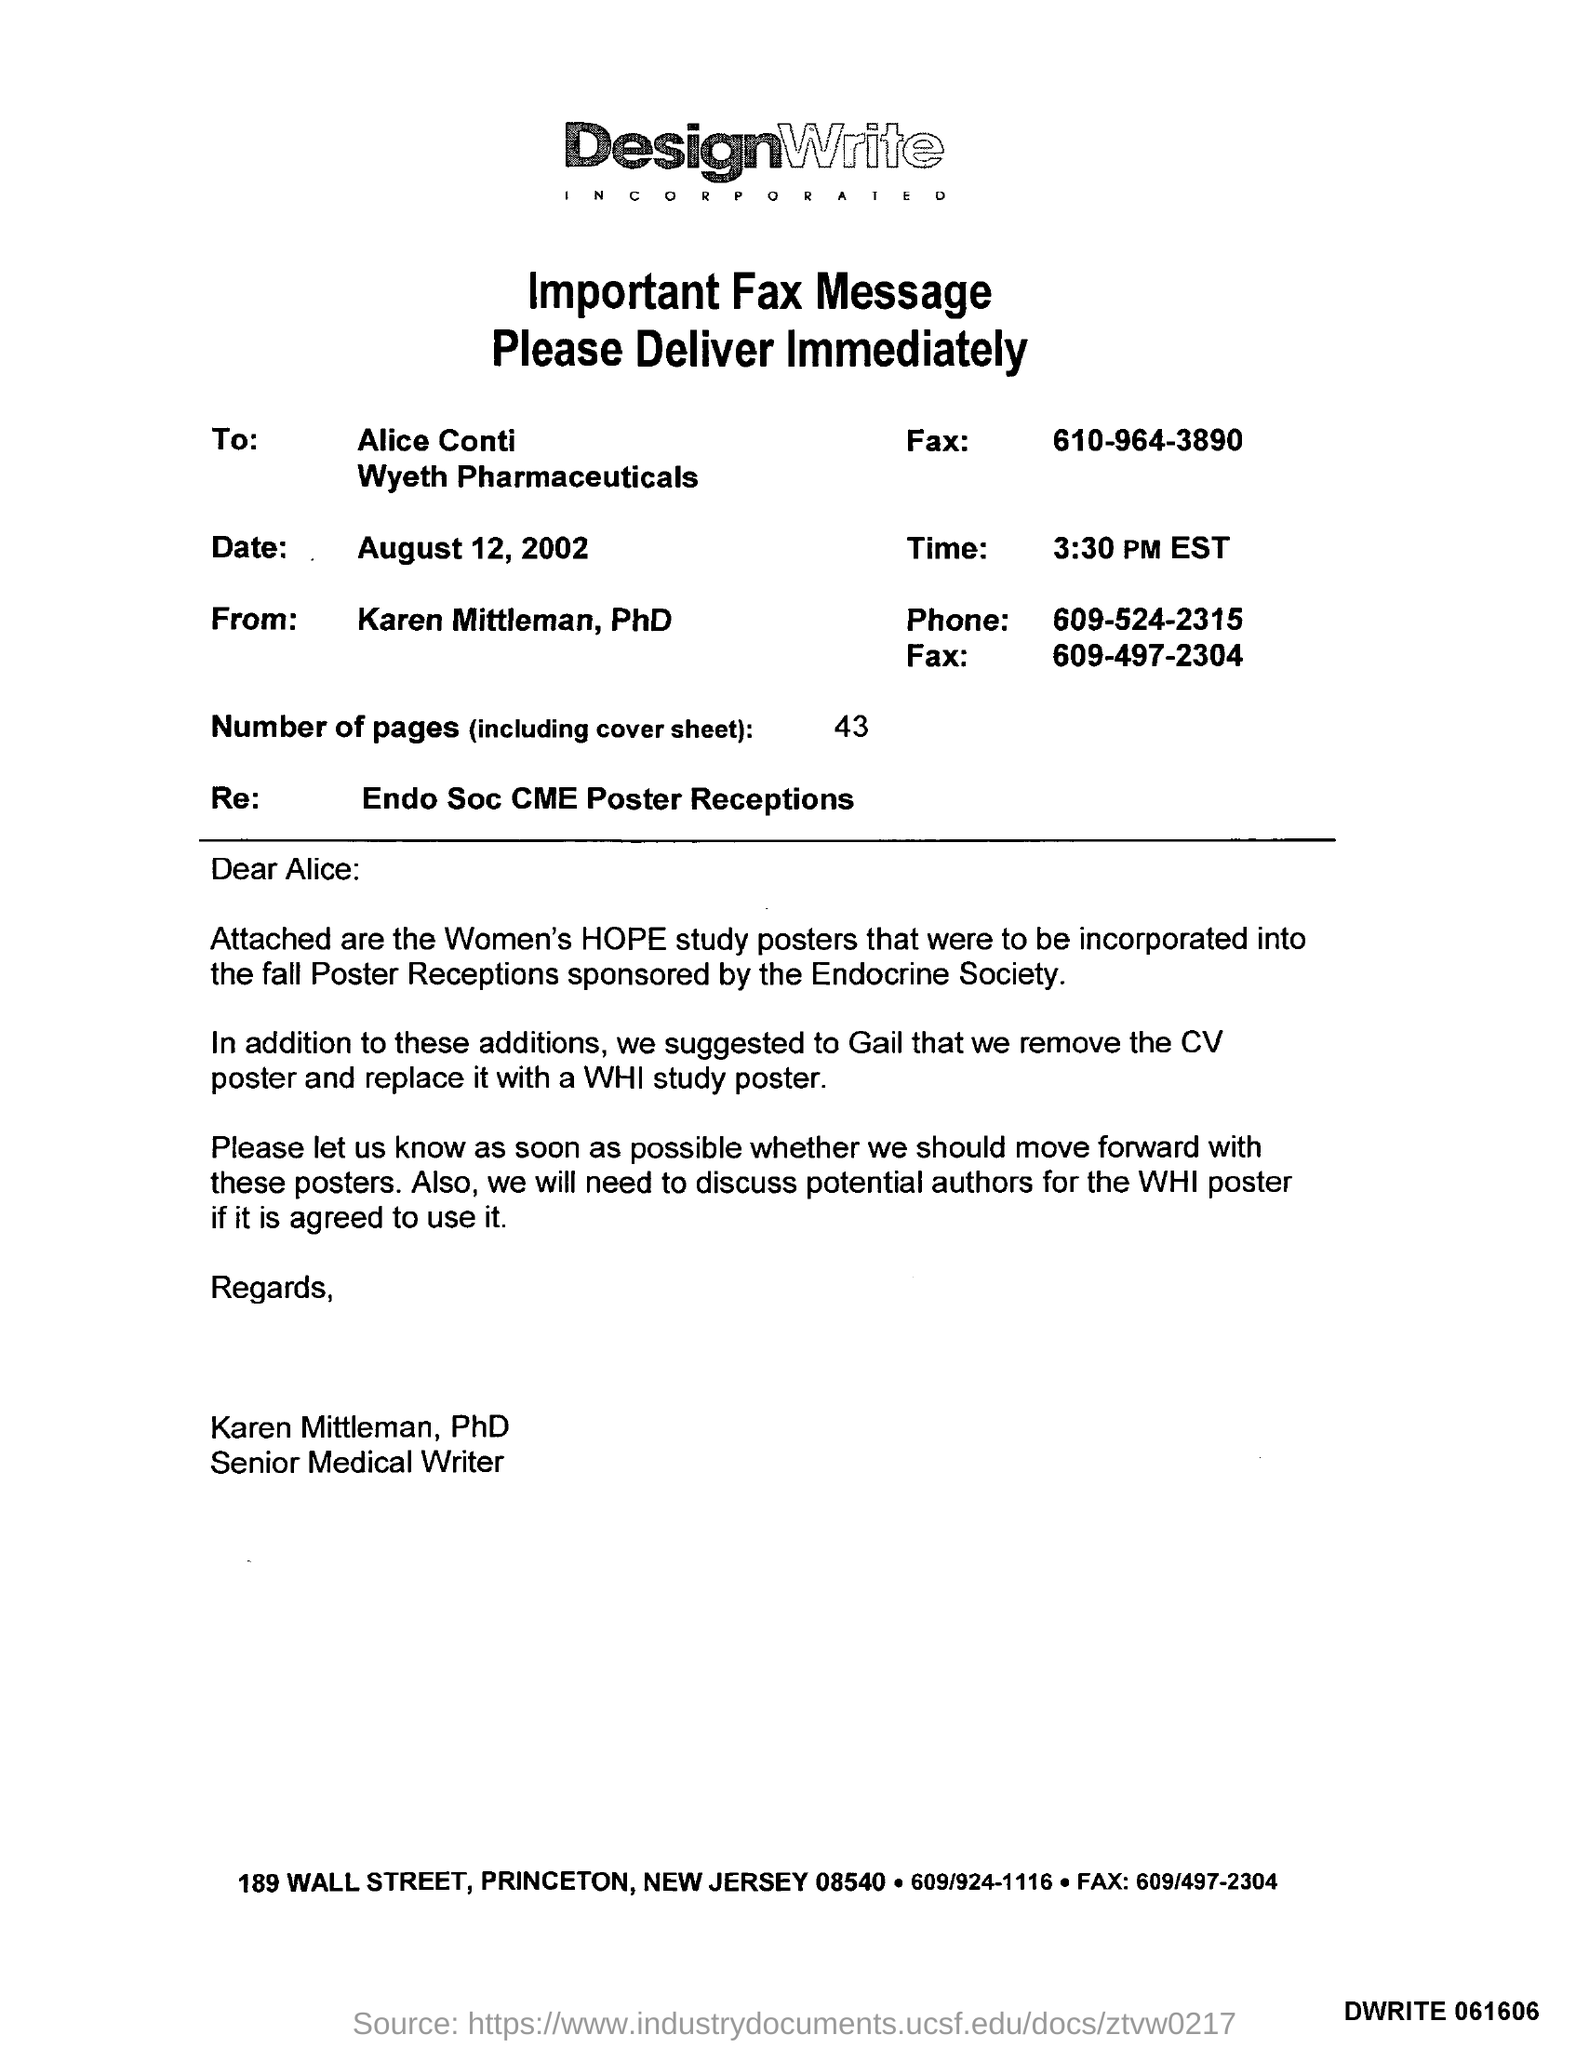Draw attention to some important aspects in this diagram. The time mentioned in the given fax message is 3:30 PM EST. There are 43 pages, including the cover sheet. The phone number mentioned in the fax is 609-524-2315. Karen Mittleman holds the designation of PhD. The email mentions "RE" in reference to Endo Soc CME poster receptions. 